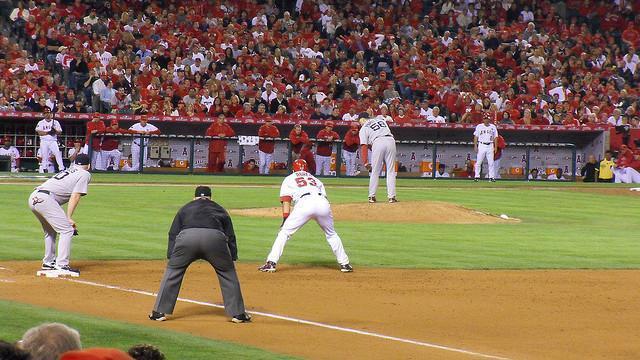How many people are visible?
Give a very brief answer. 4. 